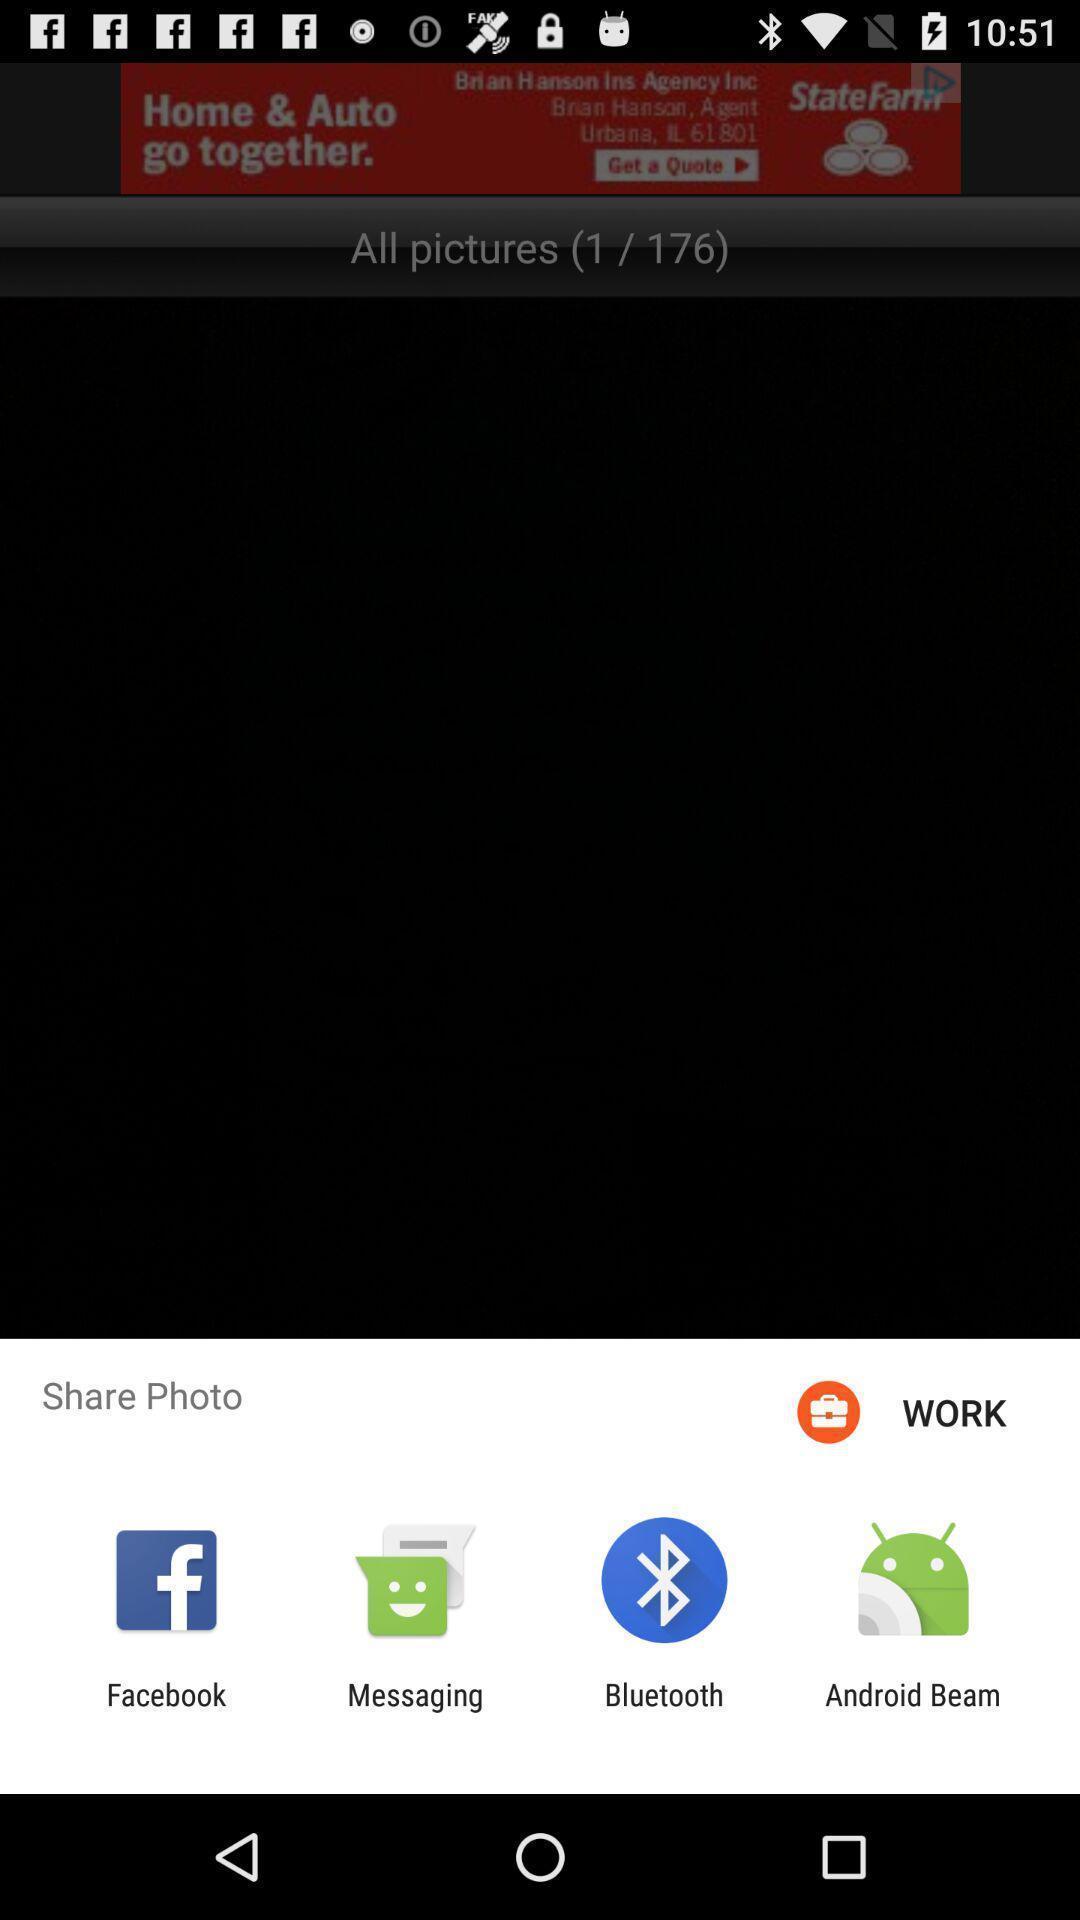Give me a summary of this screen capture. Popup showing the list of options to share a photo. 